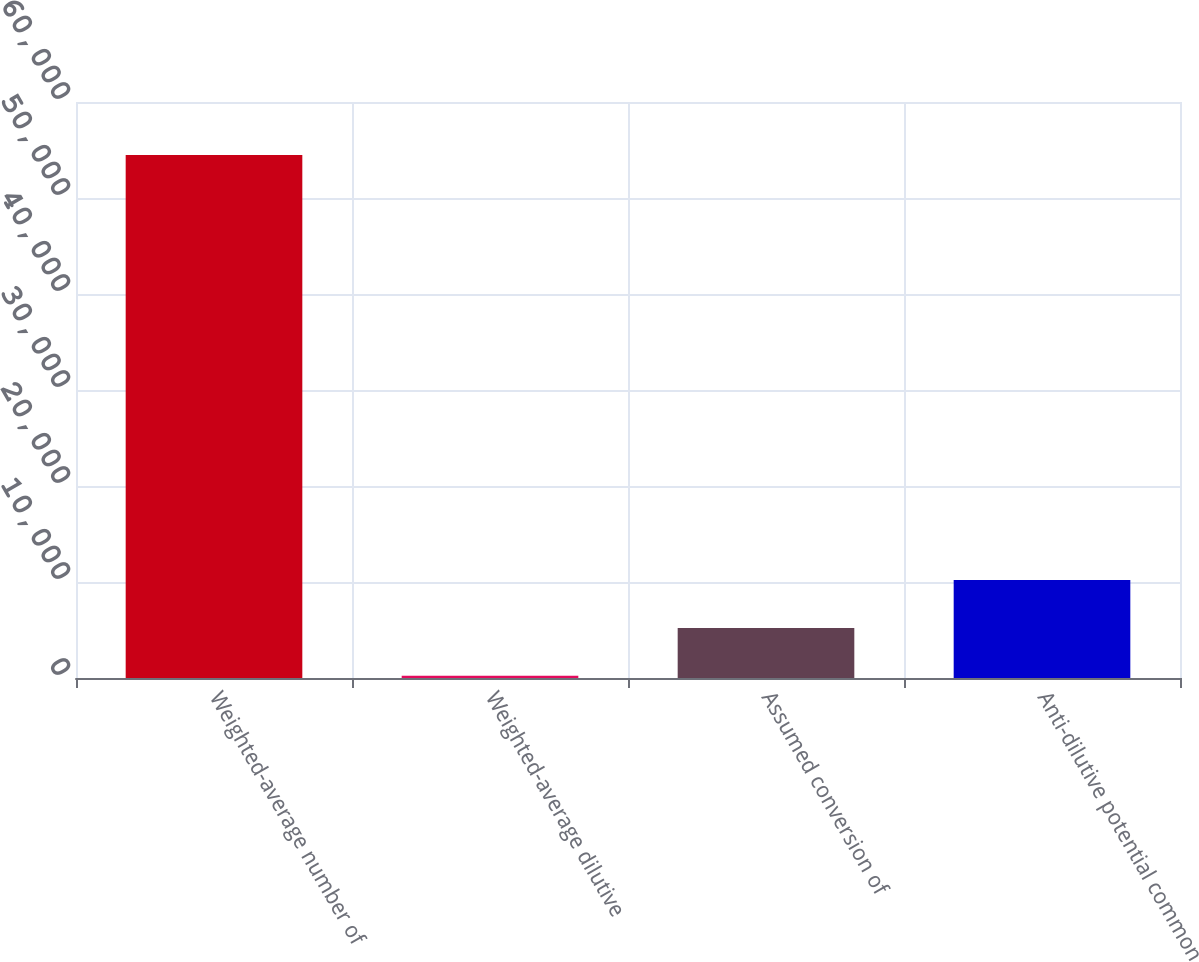Convert chart. <chart><loc_0><loc_0><loc_500><loc_500><bar_chart><fcel>Weighted-average number of<fcel>Weighted-average dilutive<fcel>Assumed conversion of<fcel>Anti-dilutive potential common<nl><fcel>54473.5<fcel>238<fcel>5220.5<fcel>10203<nl></chart> 